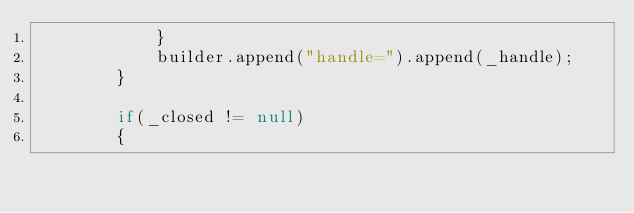<code> <loc_0><loc_0><loc_500><loc_500><_Java_>            }
            builder.append("handle=").append(_handle);
        }

        if(_closed != null)
        {</code> 